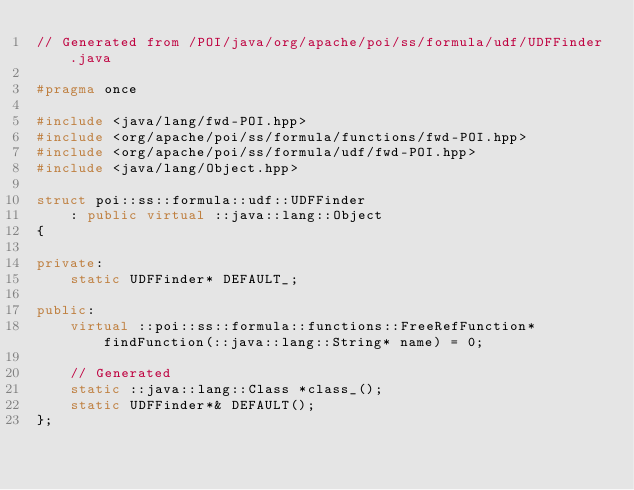<code> <loc_0><loc_0><loc_500><loc_500><_C++_>// Generated from /POI/java/org/apache/poi/ss/formula/udf/UDFFinder.java

#pragma once

#include <java/lang/fwd-POI.hpp>
#include <org/apache/poi/ss/formula/functions/fwd-POI.hpp>
#include <org/apache/poi/ss/formula/udf/fwd-POI.hpp>
#include <java/lang/Object.hpp>

struct poi::ss::formula::udf::UDFFinder
    : public virtual ::java::lang::Object
{

private:
    static UDFFinder* DEFAULT_;

public:
    virtual ::poi::ss::formula::functions::FreeRefFunction* findFunction(::java::lang::String* name) = 0;

    // Generated
    static ::java::lang::Class *class_();
    static UDFFinder*& DEFAULT();
};
</code> 